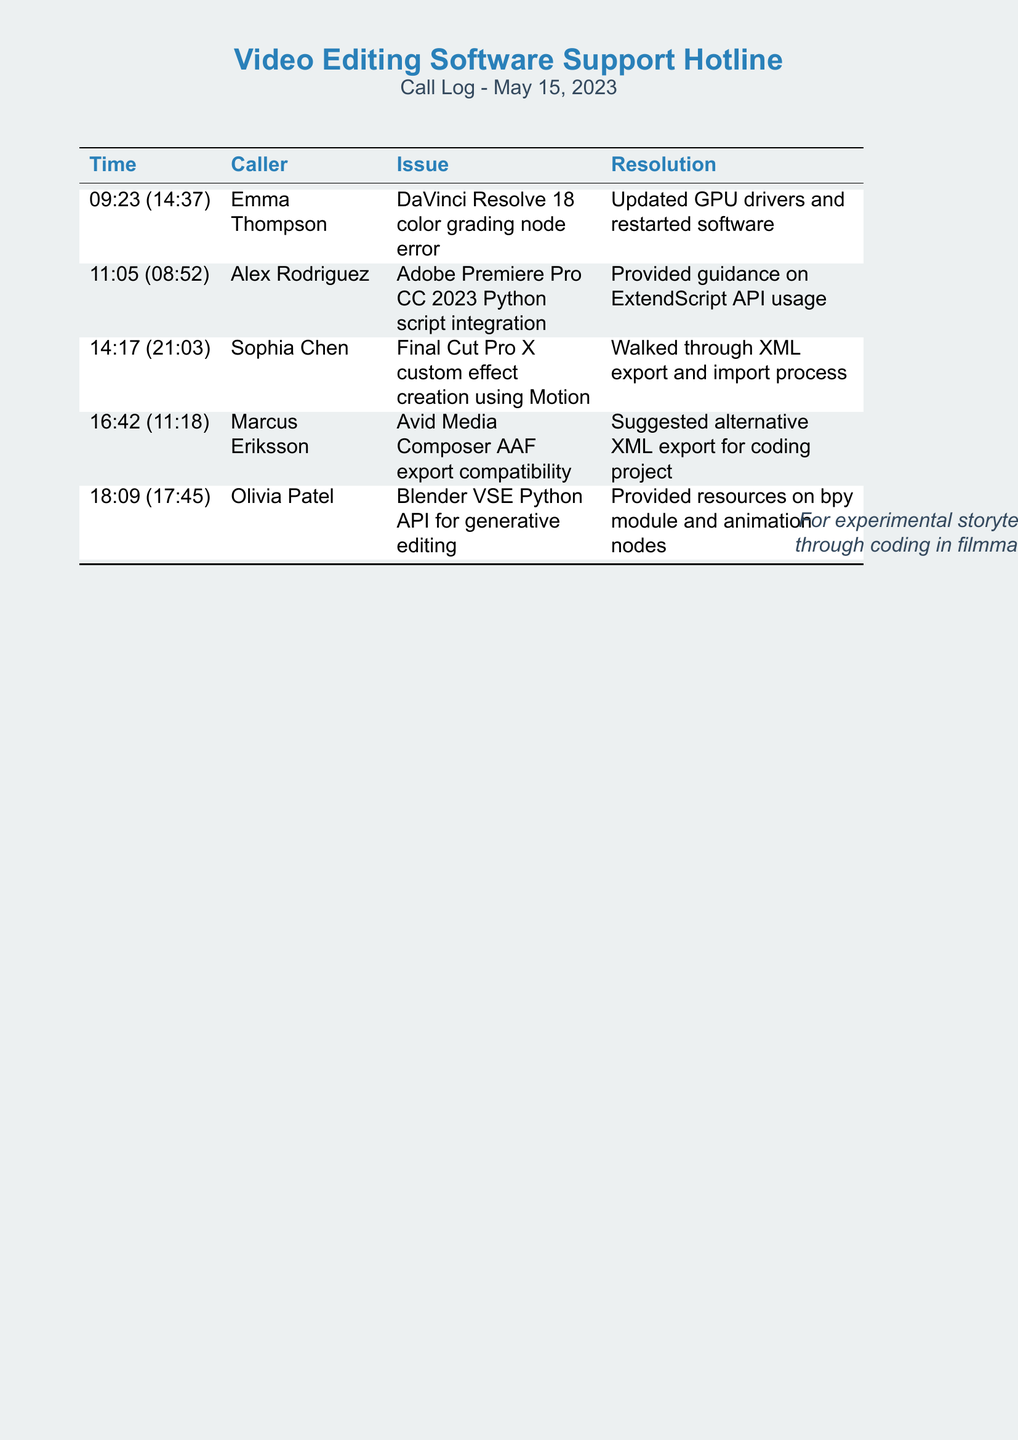what is the first caller's name? The first caller listed in the document is Emma Thompson, appearing in the first row of the call log.
Answer: Emma Thompson what time did the third call start? The start time of the third call is indicated in the "Time" column, which is 14:17.
Answer: 14:17 how long was the last call? The duration of the last call is found in parentheses next to the time, which is 17:45.
Answer: 17:45 what issue did Marcus Eriksson report? The issue reported by Marcus Eriksson details Avid Media Composer AAF export compatibility, as listed in the second column.
Answer: AAF export compatibility which caller received guidance on ExtendScript API? The caller who received guidance related to ExtendScript API was Alex Rodriguez, as noted in the call log.
Answer: Alex Rodriguez how many calls are recorded in total? The total number of calls can be counted in the call log table, which contains five entries.
Answer: 5 which software was associated with the second call? The software linked to the second call is Adobe Premiere Pro CC 2023, as mentioned in the issue column.
Answer: Adobe Premiere Pro CC 2023 what resolution was provided for the first call? The resolution for the first call involved updating GPU drivers and restarting the software, as detailed in the last column of the first row.
Answer: Updated GPU drivers and restarted software which caller had the longest call duration? The longest call duration overall is 21:03, belonging to the caller Sophia Chen.
Answer: Sophia Chen 